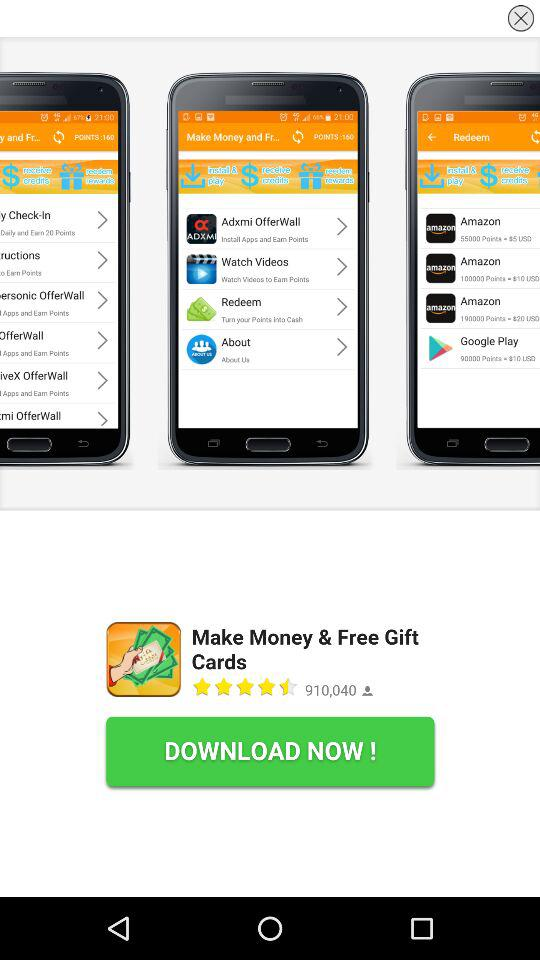What is the total number of reviews for "Make Money & Free Gift Cards"? The total number of reviews is 910,040. 